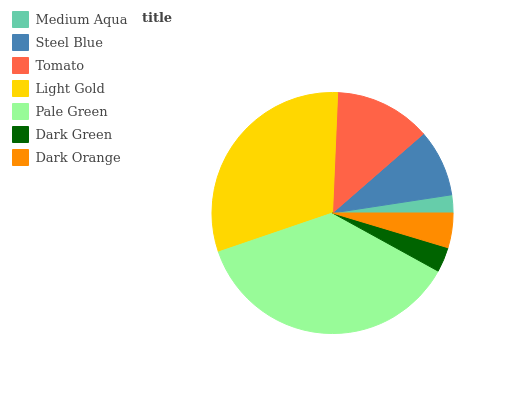Is Medium Aqua the minimum?
Answer yes or no. Yes. Is Pale Green the maximum?
Answer yes or no. Yes. Is Steel Blue the minimum?
Answer yes or no. No. Is Steel Blue the maximum?
Answer yes or no. No. Is Steel Blue greater than Medium Aqua?
Answer yes or no. Yes. Is Medium Aqua less than Steel Blue?
Answer yes or no. Yes. Is Medium Aqua greater than Steel Blue?
Answer yes or no. No. Is Steel Blue less than Medium Aqua?
Answer yes or no. No. Is Steel Blue the high median?
Answer yes or no. Yes. Is Steel Blue the low median?
Answer yes or no. Yes. Is Medium Aqua the high median?
Answer yes or no. No. Is Pale Green the low median?
Answer yes or no. No. 